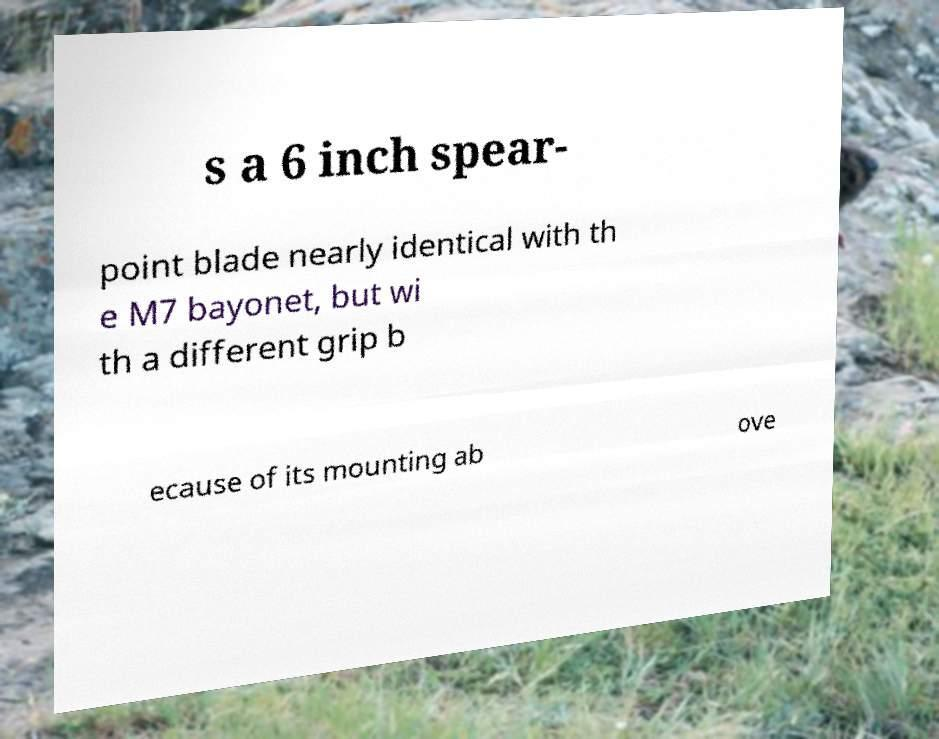Could you extract and type out the text from this image? s a 6 inch spear- point blade nearly identical with th e M7 bayonet, but wi th a different grip b ecause of its mounting ab ove 